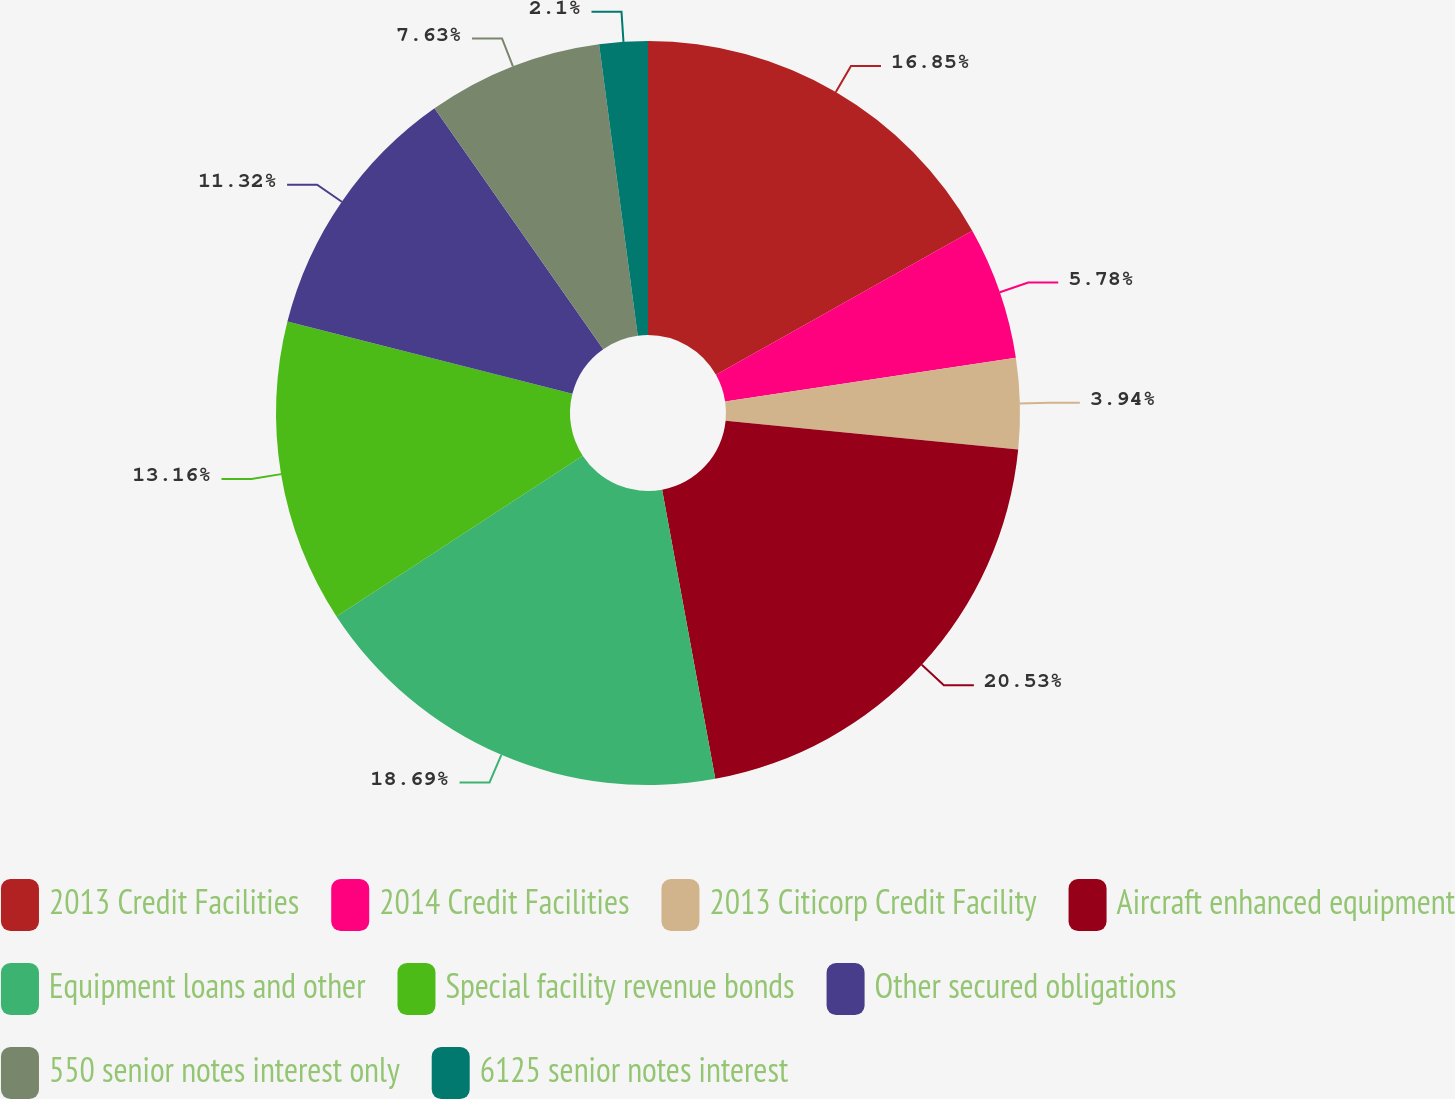Convert chart. <chart><loc_0><loc_0><loc_500><loc_500><pie_chart><fcel>2013 Credit Facilities<fcel>2014 Credit Facilities<fcel>2013 Citicorp Credit Facility<fcel>Aircraft enhanced equipment<fcel>Equipment loans and other<fcel>Special facility revenue bonds<fcel>Other secured obligations<fcel>550 senior notes interest only<fcel>6125 senior notes interest<nl><fcel>16.85%<fcel>5.78%<fcel>3.94%<fcel>20.54%<fcel>18.69%<fcel>13.16%<fcel>11.32%<fcel>7.63%<fcel>2.1%<nl></chart> 